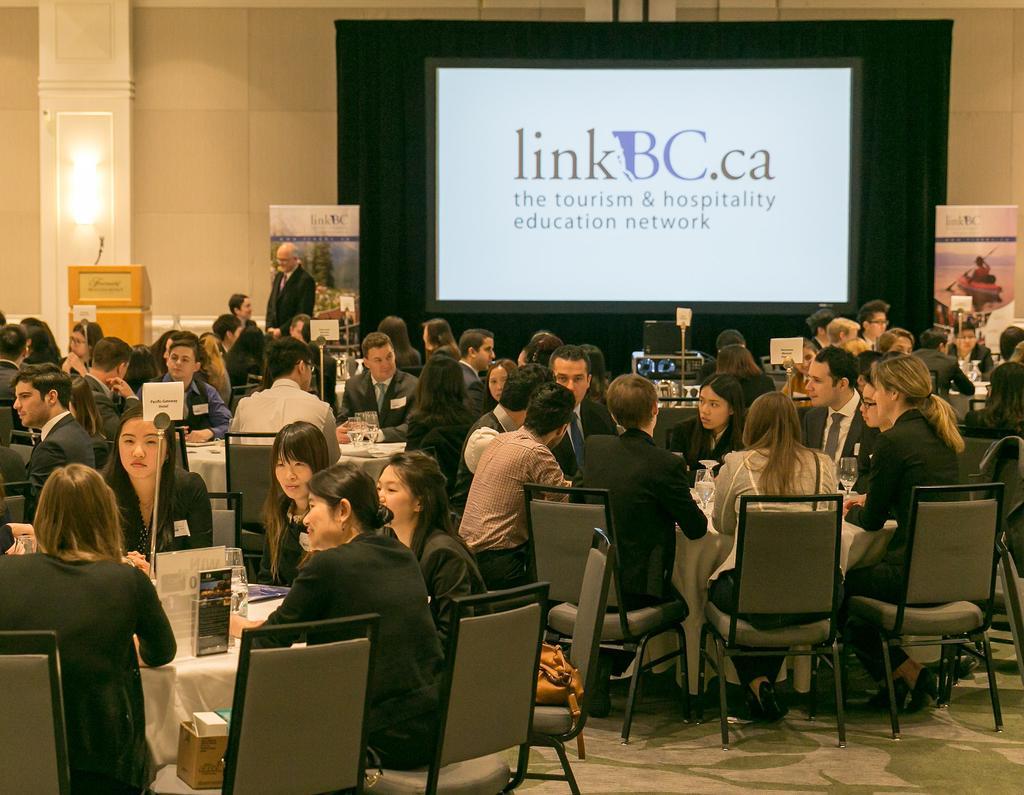Could you give a brief overview of what you see in this image? People are sitting on the table we have glass,here there is screen and the wall. 